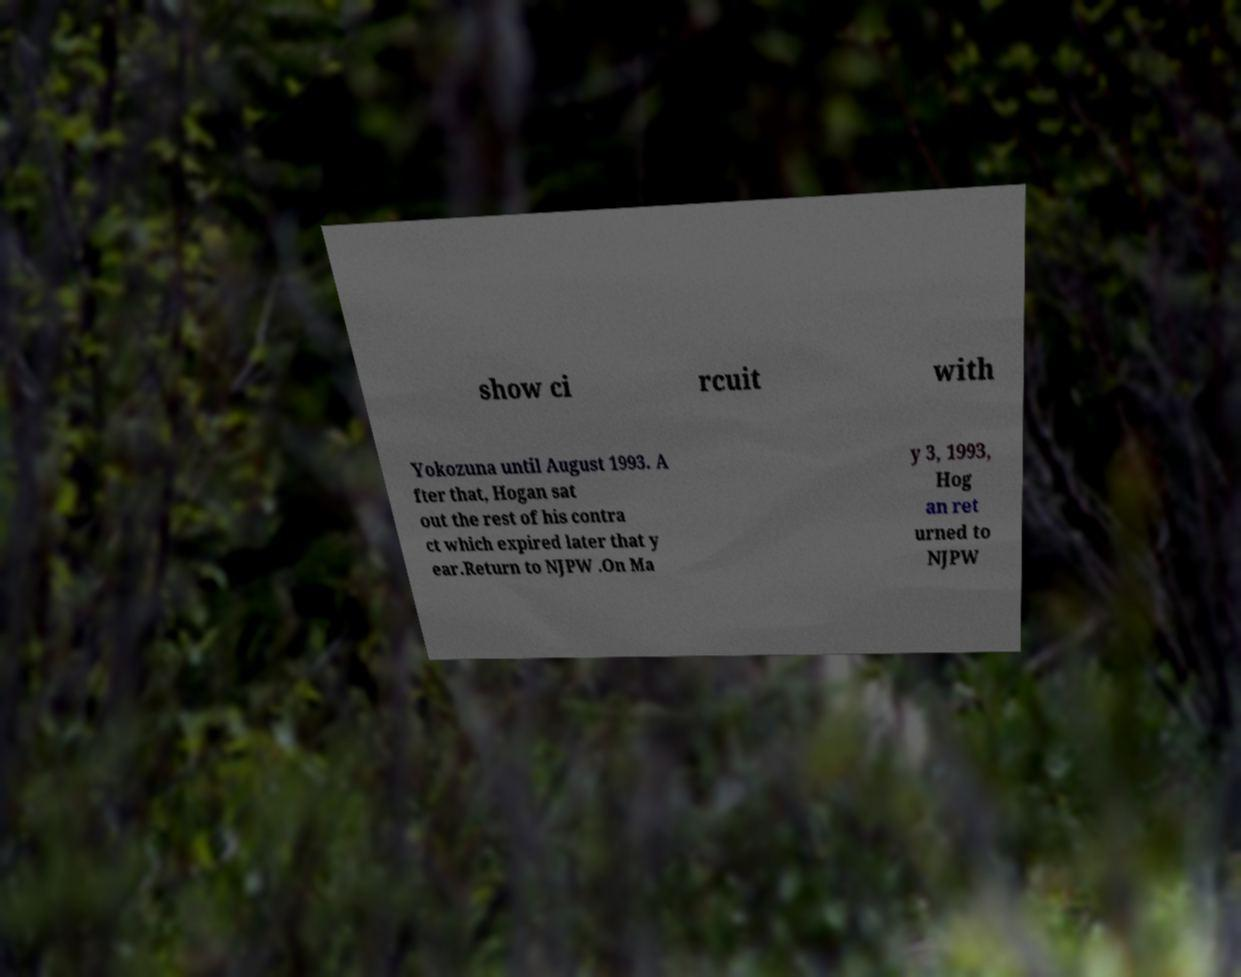What messages or text are displayed in this image? I need them in a readable, typed format. show ci rcuit with Yokozuna until August 1993. A fter that, Hogan sat out the rest of his contra ct which expired later that y ear.Return to NJPW .On Ma y 3, 1993, Hog an ret urned to NJPW 